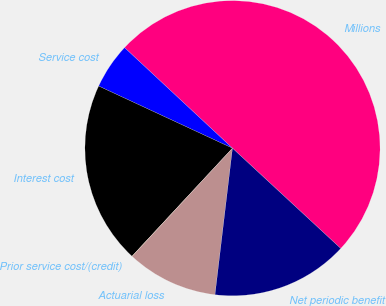<chart> <loc_0><loc_0><loc_500><loc_500><pie_chart><fcel>Millions<fcel>Service cost<fcel>Interest cost<fcel>Prior service cost/(credit)<fcel>Actuarial loss<fcel>Net periodic benefit<nl><fcel>49.95%<fcel>5.02%<fcel>20.0%<fcel>0.02%<fcel>10.01%<fcel>15.0%<nl></chart> 